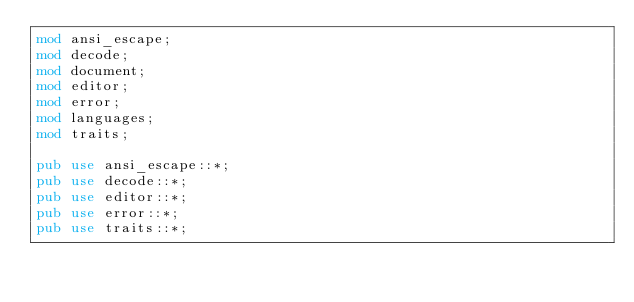<code> <loc_0><loc_0><loc_500><loc_500><_Rust_>mod ansi_escape;
mod decode;
mod document;
mod editor;
mod error;
mod languages;
mod traits;

pub use ansi_escape::*;
pub use decode::*;
pub use editor::*;
pub use error::*;
pub use traits::*;
</code> 